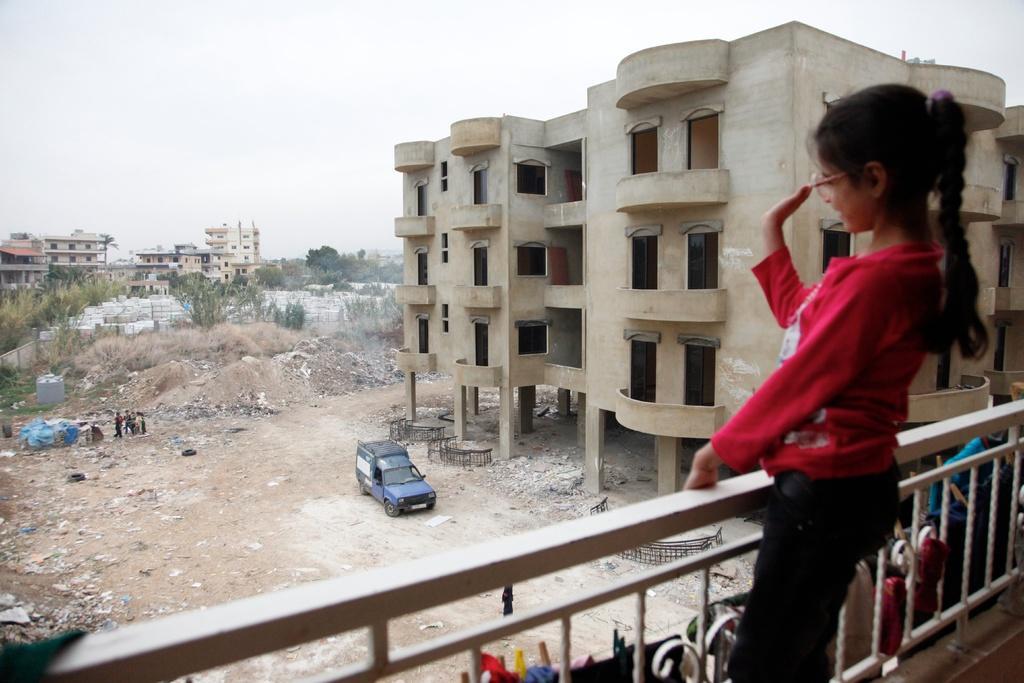Can you describe this image briefly? In this image I can see a fence , in front of fence I can see a girl, at the bottom ,in the middle there are buildings ,vehicles , persons, trees visible on the left side ,at the top there is the sky. 